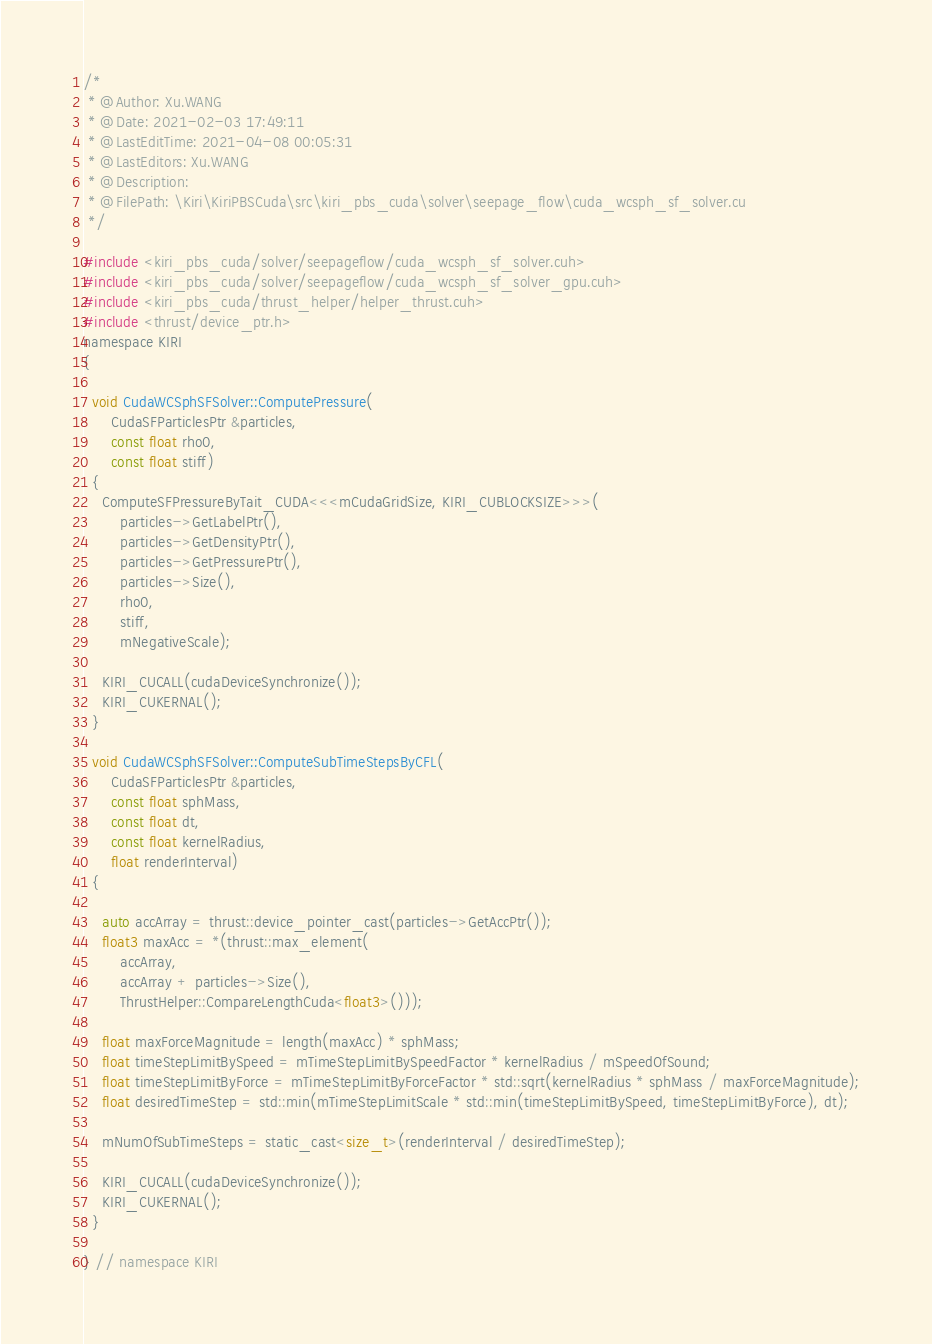Convert code to text. <code><loc_0><loc_0><loc_500><loc_500><_Cuda_>/*
 * @Author: Xu.WANG
 * @Date: 2021-02-03 17:49:11
 * @LastEditTime: 2021-04-08 00:05:31
 * @LastEditors: Xu.WANG
 * @Description: 
 * @FilePath: \Kiri\KiriPBSCuda\src\kiri_pbs_cuda\solver\seepage_flow\cuda_wcsph_sf_solver.cu
 */

#include <kiri_pbs_cuda/solver/seepageflow/cuda_wcsph_sf_solver.cuh>
#include <kiri_pbs_cuda/solver/seepageflow/cuda_wcsph_sf_solver_gpu.cuh>
#include <kiri_pbs_cuda/thrust_helper/helper_thrust.cuh>
#include <thrust/device_ptr.h>
namespace KIRI
{

  void CudaWCSphSFSolver::ComputePressure(
      CudaSFParticlesPtr &particles,
      const float rho0,
      const float stiff)
  {
    ComputeSFPressureByTait_CUDA<<<mCudaGridSize, KIRI_CUBLOCKSIZE>>>(
        particles->GetLabelPtr(),
        particles->GetDensityPtr(),
        particles->GetPressurePtr(),
        particles->Size(),
        rho0,
        stiff,
        mNegativeScale);

    KIRI_CUCALL(cudaDeviceSynchronize());
    KIRI_CUKERNAL();
  }

  void CudaWCSphSFSolver::ComputeSubTimeStepsByCFL(
      CudaSFParticlesPtr &particles,
      const float sphMass,
      const float dt,
      const float kernelRadius,
      float renderInterval)
  {

    auto accArray = thrust::device_pointer_cast(particles->GetAccPtr());
    float3 maxAcc = *(thrust::max_element(
        accArray,
        accArray + particles->Size(),
        ThrustHelper::CompareLengthCuda<float3>()));

    float maxForceMagnitude = length(maxAcc) * sphMass;
    float timeStepLimitBySpeed = mTimeStepLimitBySpeedFactor * kernelRadius / mSpeedOfSound;
    float timeStepLimitByForce = mTimeStepLimitByForceFactor * std::sqrt(kernelRadius * sphMass / maxForceMagnitude);
    float desiredTimeStep = std::min(mTimeStepLimitScale * std::min(timeStepLimitBySpeed, timeStepLimitByForce), dt);

    mNumOfSubTimeSteps = static_cast<size_t>(renderInterval / desiredTimeStep);

    KIRI_CUCALL(cudaDeviceSynchronize());
    KIRI_CUKERNAL();
  }

} // namespace KIRI
</code> 